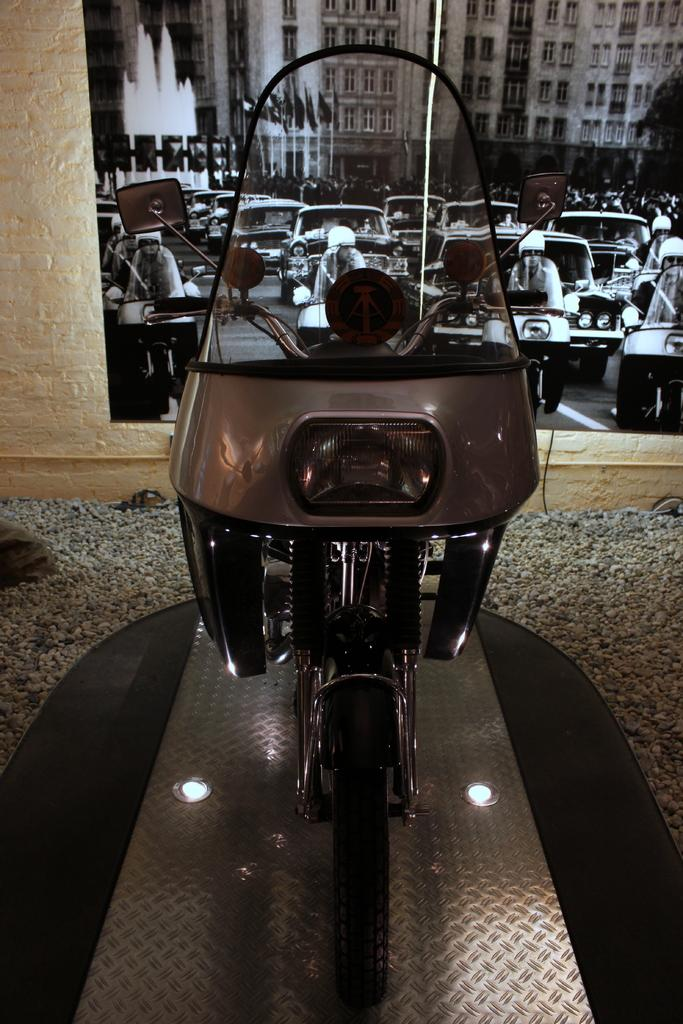What is the main subject in the foreground of the image? There is a vehicle in the foreground of the image. What can be seen in the background of the image? There are vehicles, buildings, flags, a water fountain, and other objects visible in the background of the image. How many vehicles can be seen in the image? There is one vehicle in the foreground and multiple vehicles visible in the background, so there are at least two vehicles in the image. What type of stitch is being used to sew the umbrella in the image? There is no umbrella or stitching present in the image. How many needles are visible in the image? There are no needles visible in the image. 